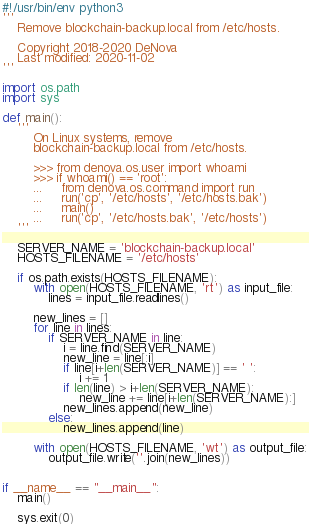Convert code to text. <code><loc_0><loc_0><loc_500><loc_500><_Python_>#!/usr/bin/env python3
'''
    Remove blockchain-backup.local from /etc/hosts.

    Copyright 2018-2020 DeNova
    Last modified: 2020-11-02
'''

import os.path
import sys

def main():
    '''
        On Linux systems, remove
        blockchain-backup.local from /etc/hosts.

        >>> from denova.os.user import whoami
        >>> if whoami() == 'root':
        ...     from denova.os.command import run
        ...     run('cp', '/etc/hosts', '/etc/hosts.bak')
        ...     main()
        ...     run('cp', '/etc/hosts.bak', '/etc/hosts')
    '''

    SERVER_NAME = 'blockchain-backup.local'
    HOSTS_FILENAME = '/etc/hosts'

    if os.path.exists(HOSTS_FILENAME):
        with open(HOSTS_FILENAME, 'rt') as input_file:
            lines = input_file.readlines()

        new_lines = []
        for line in lines:
            if SERVER_NAME in line:
                i = line.find(SERVER_NAME)
                new_line = line[:i]
                if line[i+len(SERVER_NAME)] == ' ':
                    i += 1
                if len(line) > i+len(SERVER_NAME):
                    new_line += line[i+len(SERVER_NAME):]
                new_lines.append(new_line)
            else:
                new_lines.append(line)

        with open(HOSTS_FILENAME, 'wt') as output_file:
            output_file.write(''.join(new_lines))


if __name__ == "__main__":
    main()

    sys.exit(0)
</code> 